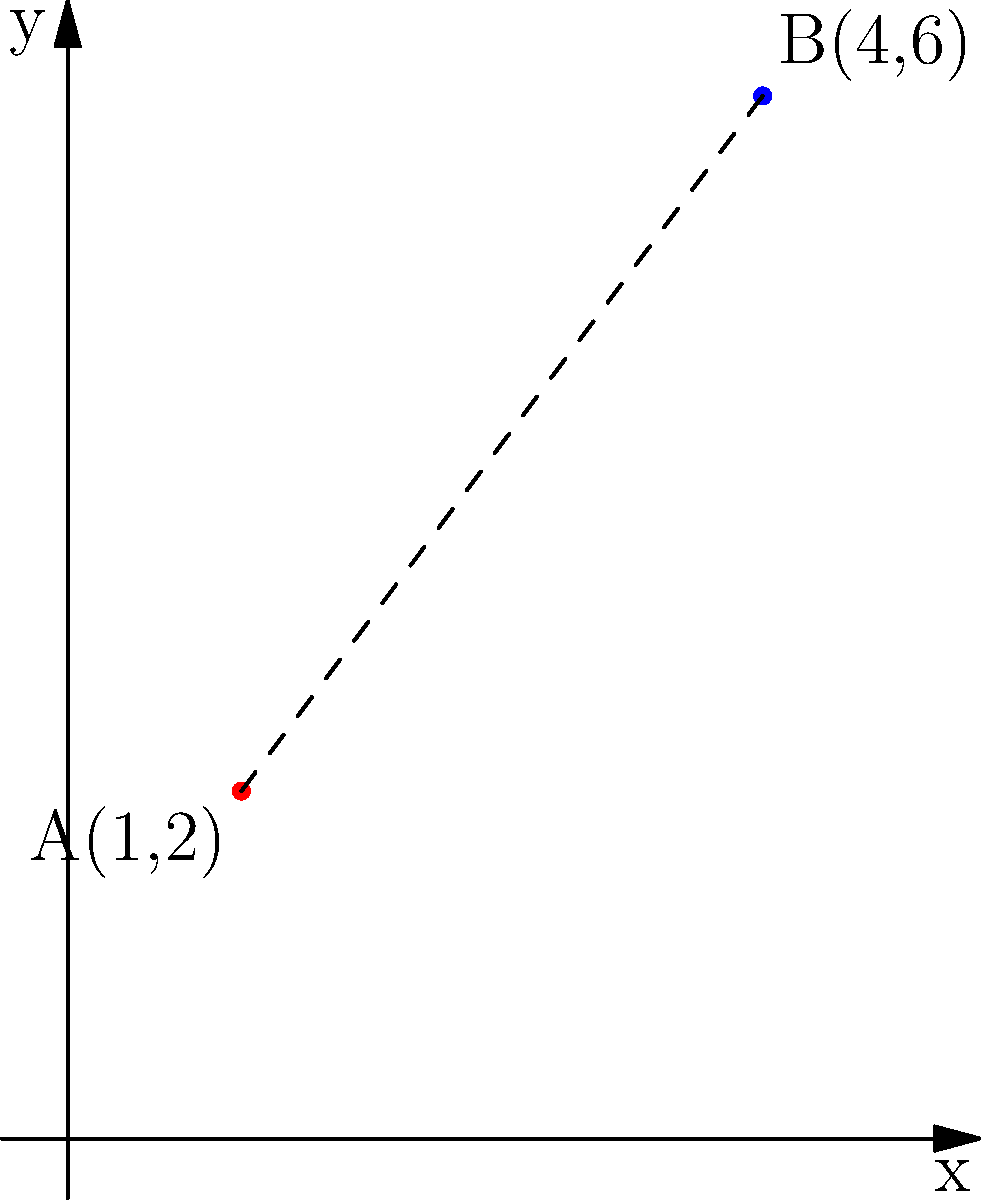In a coordinate plane representing the locations of diplomatic offices in Canberra, Australia, two points A(1,2) and B(4,6) represent the positions of the US and Chinese embassies, respectively. Calculate the distance between these two diplomatic offices using the distance formula. Round your answer to two decimal places. To find the distance between two points in a coordinate plane, we use the distance formula:

$$d = \sqrt{(x_2 - x_1)^2 + (y_2 - y_1)^2}$$

Where $(x_1, y_1)$ represents the coordinates of the first point and $(x_2, y_2)$ represents the coordinates of the second point.

Given:
Point A (US Embassy): $(1, 2)$
Point B (Chinese Embassy): $(4, 6)$

Step 1: Substitute the values into the distance formula:
$$d = \sqrt{(4 - 1)^2 + (6 - 2)^2}$$

Step 2: Simplify the expressions inside the parentheses:
$$d = \sqrt{3^2 + 4^2}$$

Step 3: Calculate the squares:
$$d = \sqrt{9 + 16}$$

Step 4: Add the values under the square root:
$$d = \sqrt{25}$$

Step 5: Calculate the square root:
$$d = 5$$

The exact distance between the two diplomatic offices is 5 units.
Answer: 5 units 